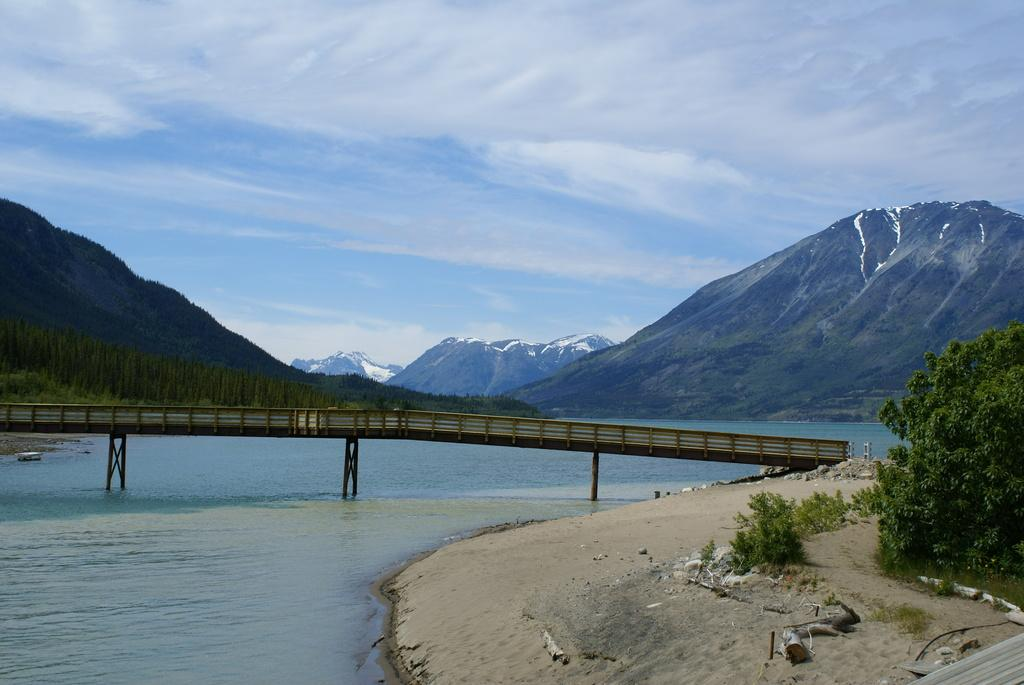What is the main structure in the center of the image? There is a bridge in the center of the image. What is the bridge positioned over? The bridge is over water. What type of natural environment is visible in the image? There is greenery in the image. What can be seen in the distance in the background of the image? There are mountains in the background of the image. How many rabbits can be seen eating crackers on the bridge in the image? There are no rabbits or crackers present in the image; it features a bridge over water with greenery and mountains in the background. 